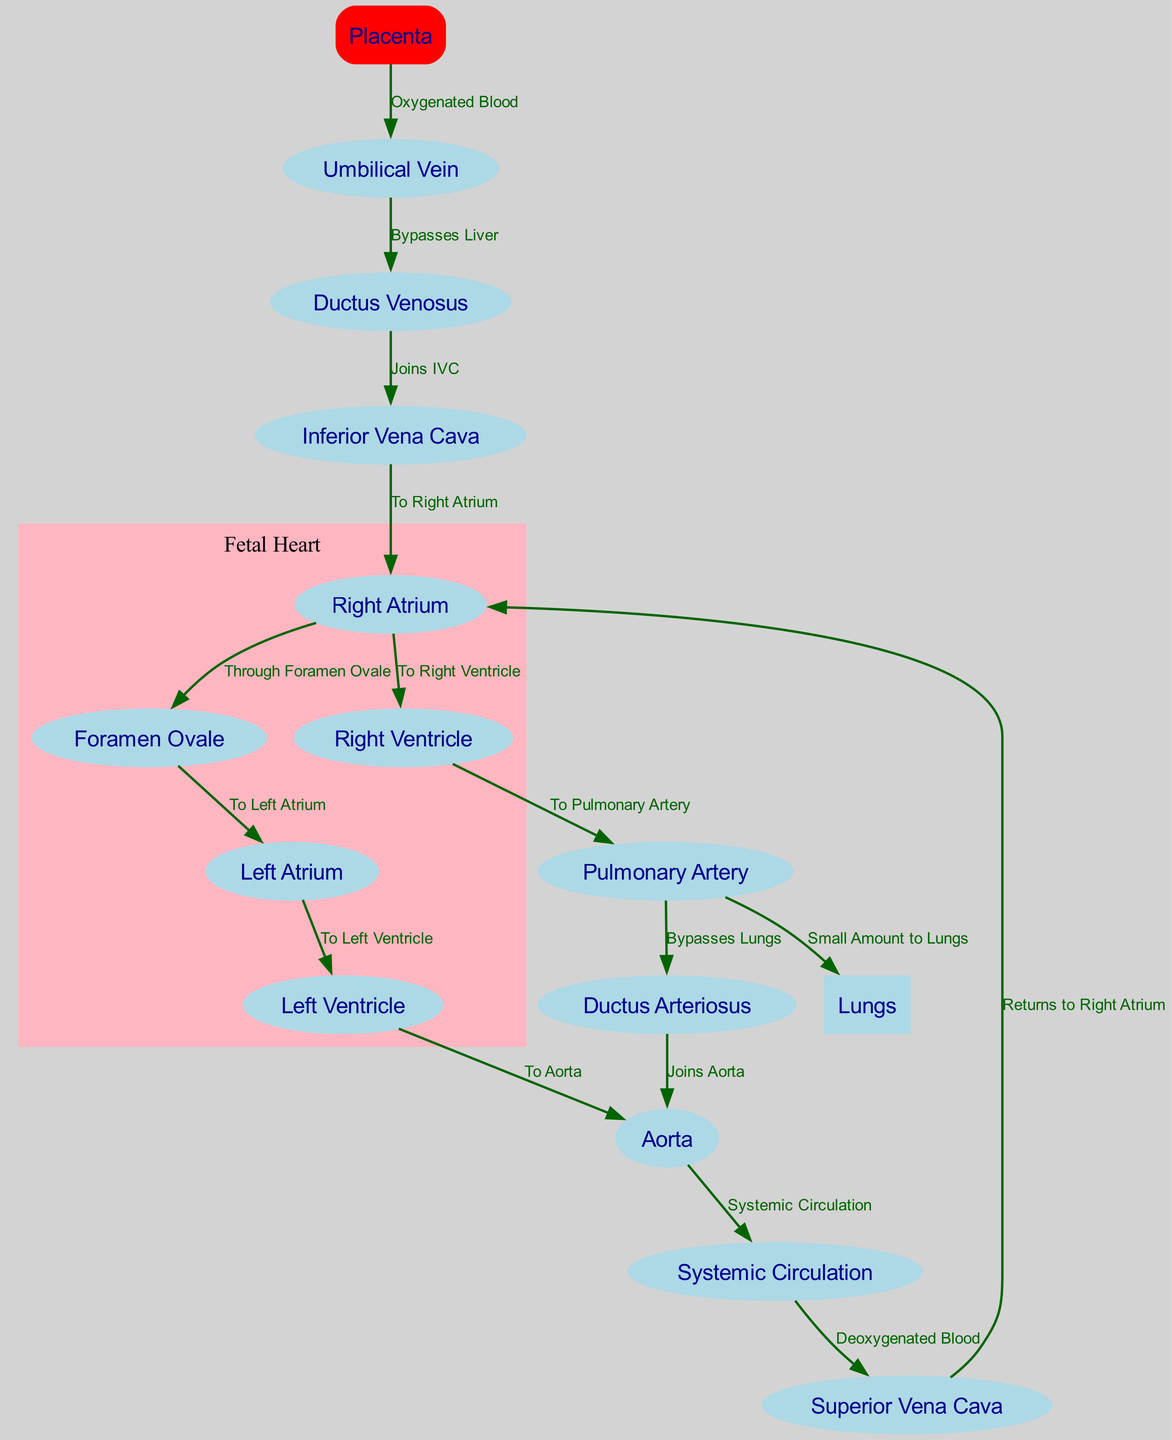What is the first node that blood exits from the placenta? The diagram indicates that the first node blood exits from the placenta is the Umbilical Vein, as the arrow leads directly from the Placenta to the Umbilical Vein labeled "Oxygenated Blood."
Answer: Umbilical Vein Which node connects the Ductus Venosus to the Inferior Vena Cava? The edge labeled "Joins IVC" shows the Ductus Venosus pointing to the Inferior Vena Cava, indicating this is the connection between the two nodes.
Answer: Inferior Vena Cava How many nodes represent parts of the fetal heart? By examining the diagram, we identify the nodes representing parts of the fetal heart: the Right Atrium, Foramen Ovale, Left Atrium, Left Ventricle, and Right Ventricle, totaling five distinct nodes.
Answer: 5 What pathway does deoxygenated blood take from the Superior Vena Cava? Following the diagram, deoxygenated blood flows from the Superior Vena Cava to the Right Atrium, then to the Right Ventricle, and finally to the Pulmonary Artery. The flow sequence demonstrates the route taken.
Answer: Right Atrium, Right Ventricle, Pulmonary Artery What small amount of blood bypasses the lungs? The diagram shows that a small amount of blood from the Pulmonary Artery goes to the Lungs, but the main pathway bypasses it through the Ductus Arteriosus that joins the Aorta. Thus, the blood that specifically bypasses the lungs is that which flows from the Pulmonary Artery to the Ductus Arteriosus.
Answer: Ductus Arteriosus Which node serves as the final destination for oxygenated blood from the Left Ventricle? The edge labeled "To Aorta" indicates that the final destination for oxygenated blood from the Left Ventricle is the Aorta, showcasing the main output into systemic circulation.
Answer: Aorta What is the pathway label for blood flow from the Umbilical Vein to the Ductus Venosus? The pathway label states "Bypasses Liver," which defines how blood from the Umbilical Vein is directed toward the Ductus Venosus, indicating that it directly skips liver circulation.
Answer: Bypasses Liver Identify the node that represents where the blood returns to the heart from systemic circulation. The flow labeled "Returns to Right Atrium" shows that blood from the Systemic Circulation comes back to the Right Atrium, making it the point of return for the circulated blood.
Answer: Right Atrium 